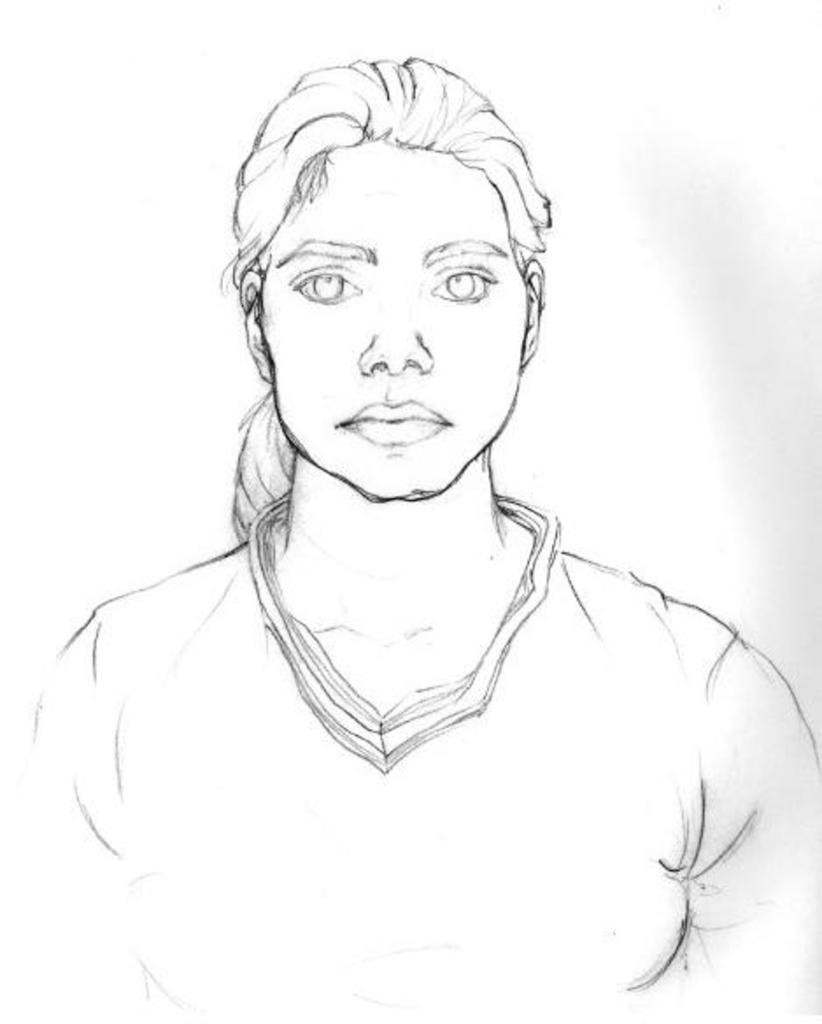What is depicted in the image? The image contains a sketch of a woman. What color is the background of the image? The background of the image is white. What type of paper is the woman using to laugh in the image? There is no woman or laughter present in the image; it contains a sketch of a woman on a white background. 